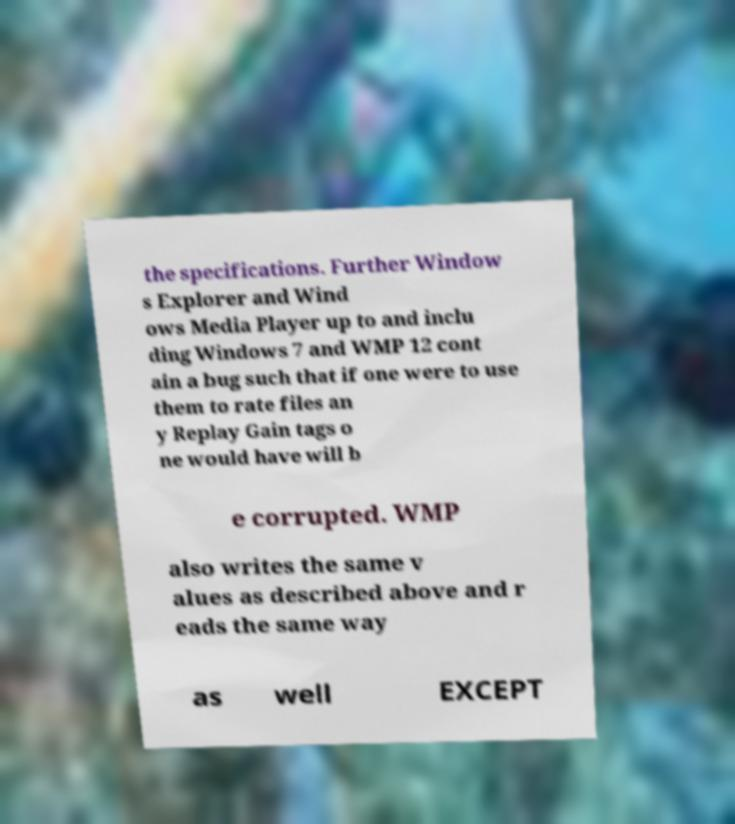I need the written content from this picture converted into text. Can you do that? the specifications. Further Window s Explorer and Wind ows Media Player up to and inclu ding Windows 7 and WMP 12 cont ain a bug such that if one were to use them to rate files an y Replay Gain tags o ne would have will b e corrupted. WMP also writes the same v alues as described above and r eads the same way as well EXCEPT 